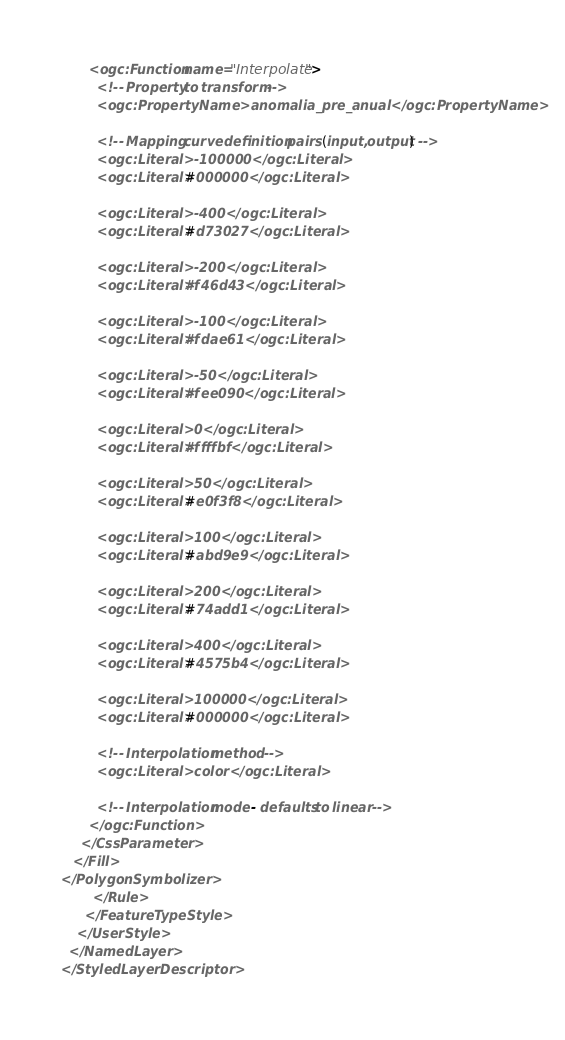<code> <loc_0><loc_0><loc_500><loc_500><_Scheme_>       <ogc:Function name="Interpolate">
         <!-- Property to transform -->
         <ogc:PropertyName>anomalia_pre_anual</ogc:PropertyName>

         <!-- Mapping curve definition pairs (input, output) -->
         <ogc:Literal>-100000</ogc:Literal>
         <ogc:Literal>#000000</ogc:Literal>

         <ogc:Literal>-400</ogc:Literal>
         <ogc:Literal>#d73027</ogc:Literal>

         <ogc:Literal>-200</ogc:Literal>
         <ogc:Literal>#f46d43</ogc:Literal>

         <ogc:Literal>-100</ogc:Literal>
         <ogc:Literal>#fdae61</ogc:Literal>
         
         <ogc:Literal>-50</ogc:Literal>
         <ogc:Literal>#fee090</ogc:Literal>

         <ogc:Literal>0</ogc:Literal>
         <ogc:Literal>#ffffbf</ogc:Literal>
         
         <ogc:Literal>50</ogc:Literal>
         <ogc:Literal>#e0f3f8</ogc:Literal>
         
         <ogc:Literal>100</ogc:Literal>
         <ogc:Literal>#abd9e9</ogc:Literal>
         
         <ogc:Literal>200</ogc:Literal>
         <ogc:Literal>#74add1</ogc:Literal>
         
         <ogc:Literal>400</ogc:Literal>
         <ogc:Literal>#4575b4</ogc:Literal> 
         
         <ogc:Literal>100000</ogc:Literal>
         <ogc:Literal>#000000</ogc:Literal>       

         <!-- Interpolation method -->
         <ogc:Literal>color</ogc:Literal>

         <!-- Interpolation mode - defaults to linear -->
       </ogc:Function>
     </CssParameter>
   </Fill>
</PolygonSymbolizer>
        </Rule>
      </FeatureTypeStyle>
    </UserStyle>
  </NamedLayer>
</StyledLayerDescriptor></code> 